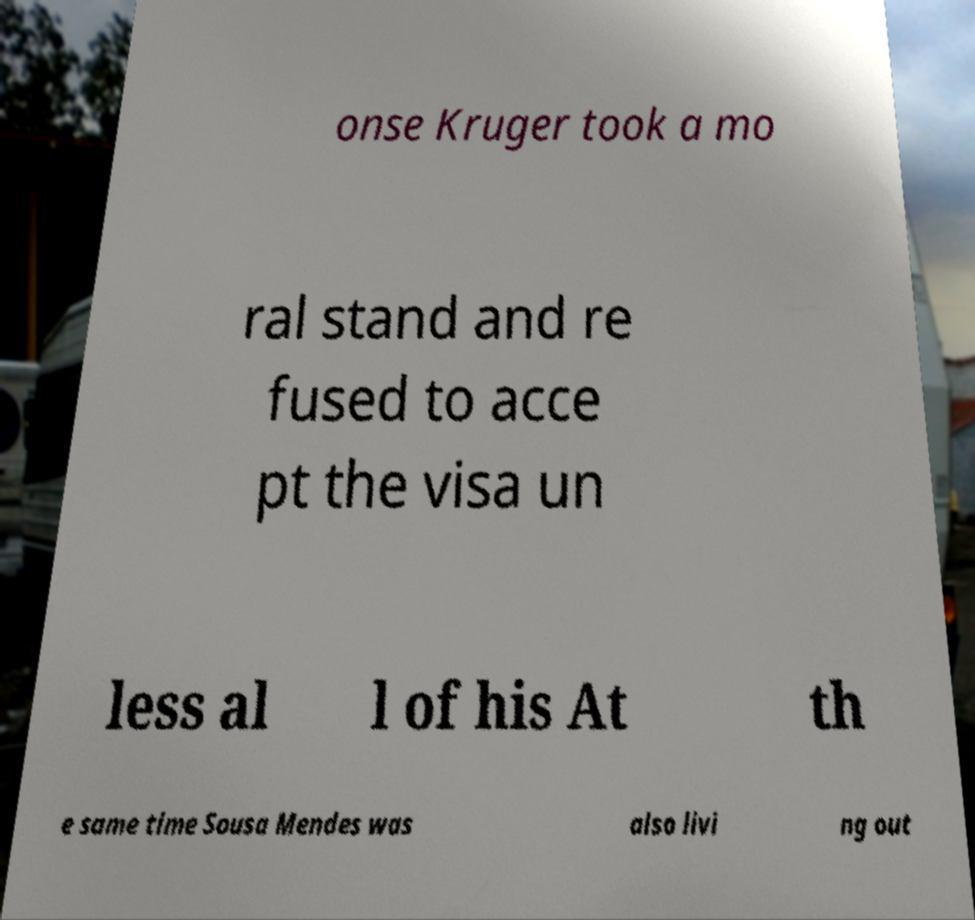Please identify and transcribe the text found in this image. onse Kruger took a mo ral stand and re fused to acce pt the visa un less al l of his At th e same time Sousa Mendes was also livi ng out 